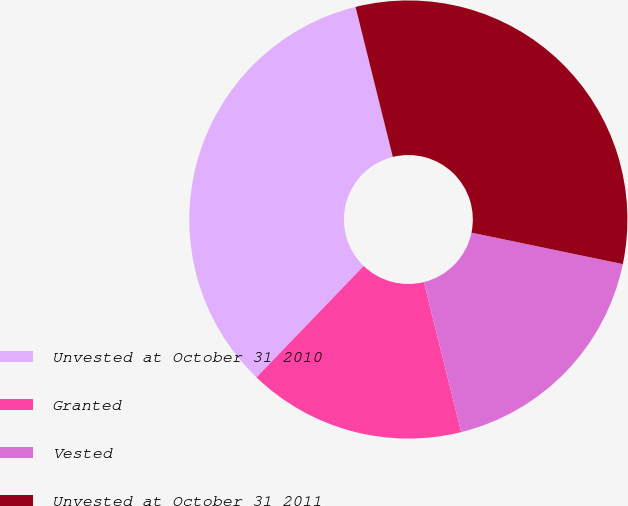Convert chart to OTSL. <chart><loc_0><loc_0><loc_500><loc_500><pie_chart><fcel>Unvested at October 31 2010<fcel>Granted<fcel>Vested<fcel>Unvested at October 31 2011<nl><fcel>33.93%<fcel>16.07%<fcel>17.86%<fcel>32.14%<nl></chart> 